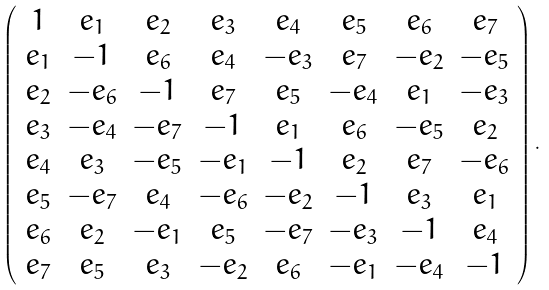<formula> <loc_0><loc_0><loc_500><loc_500>\left ( \begin{array} { c c c c c c c c } 1 & e _ { 1 } & e _ { 2 } & e _ { 3 } & e _ { 4 } & e _ { 5 } & e _ { 6 } & e _ { 7 } \\ e _ { 1 } & - 1 & e _ { 6 } & e _ { 4 } & - e _ { 3 } & e _ { 7 } & - e _ { 2 } & - e _ { 5 } \\ e _ { 2 } & - e _ { 6 } & - 1 & e _ { 7 } & e _ { 5 } & - e _ { 4 } & e _ { 1 } & - e _ { 3 } \\ e _ { 3 } & - e _ { 4 } & - e _ { 7 } & - 1 & e _ { 1 } & e _ { 6 } & - e _ { 5 } & e _ { 2 } \\ e _ { 4 } & e _ { 3 } & - e _ { 5 } & - e _ { 1 } & - 1 & e _ { 2 } & e _ { 7 } & - e _ { 6 } \\ e _ { 5 } & - e _ { 7 } & e _ { 4 } & - e _ { 6 } & - e _ { 2 } & - 1 & e _ { 3 } & e _ { 1 } \\ e _ { 6 } & e _ { 2 } & - e _ { 1 } & e _ { 5 } & - e _ { 7 } & - e _ { 3 } & - 1 & e _ { 4 } \\ e _ { 7 } & e _ { 5 } & e _ { 3 } & - e _ { 2 } & e _ { 6 } & - e _ { 1 } & - e _ { 4 } & - 1 \\ \end{array} \right ) .</formula> 